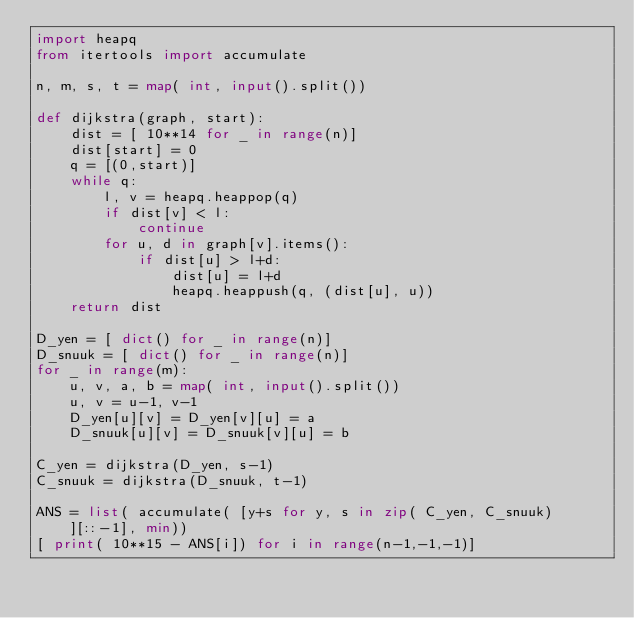Convert code to text. <code><loc_0><loc_0><loc_500><loc_500><_Python_>import heapq
from itertools import accumulate

n, m, s, t = map( int, input().split())

def dijkstra(graph, start):
    dist = [ 10**14 for _ in range(n)]
    dist[start] = 0
    q = [(0,start)]
    while q:
        l, v = heapq.heappop(q)
        if dist[v] < l:
            continue
        for u, d in graph[v].items():
            if dist[u] > l+d:
                dist[u] = l+d
                heapq.heappush(q, (dist[u], u))
    return dist

D_yen = [ dict() for _ in range(n)]
D_snuuk = [ dict() for _ in range(n)]
for _ in range(m):
    u, v, a, b = map( int, input().split())
    u, v = u-1, v-1
    D_yen[u][v] = D_yen[v][u] = a
    D_snuuk[u][v] = D_snuuk[v][u] = b

C_yen = dijkstra(D_yen, s-1)
C_snuuk = dijkstra(D_snuuk, t-1)

ANS = list( accumulate( [y+s for y, s in zip( C_yen, C_snuuk)][::-1], min))
[ print( 10**15 - ANS[i]) for i in range(n-1,-1,-1)]</code> 